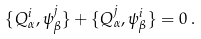Convert formula to latex. <formula><loc_0><loc_0><loc_500><loc_500>\{ Q ^ { i } _ { \alpha } , \psi ^ { j } _ { \beta } \} + \{ Q ^ { j } _ { \alpha } , \psi ^ { i } _ { \beta } \} = 0 \, .</formula> 